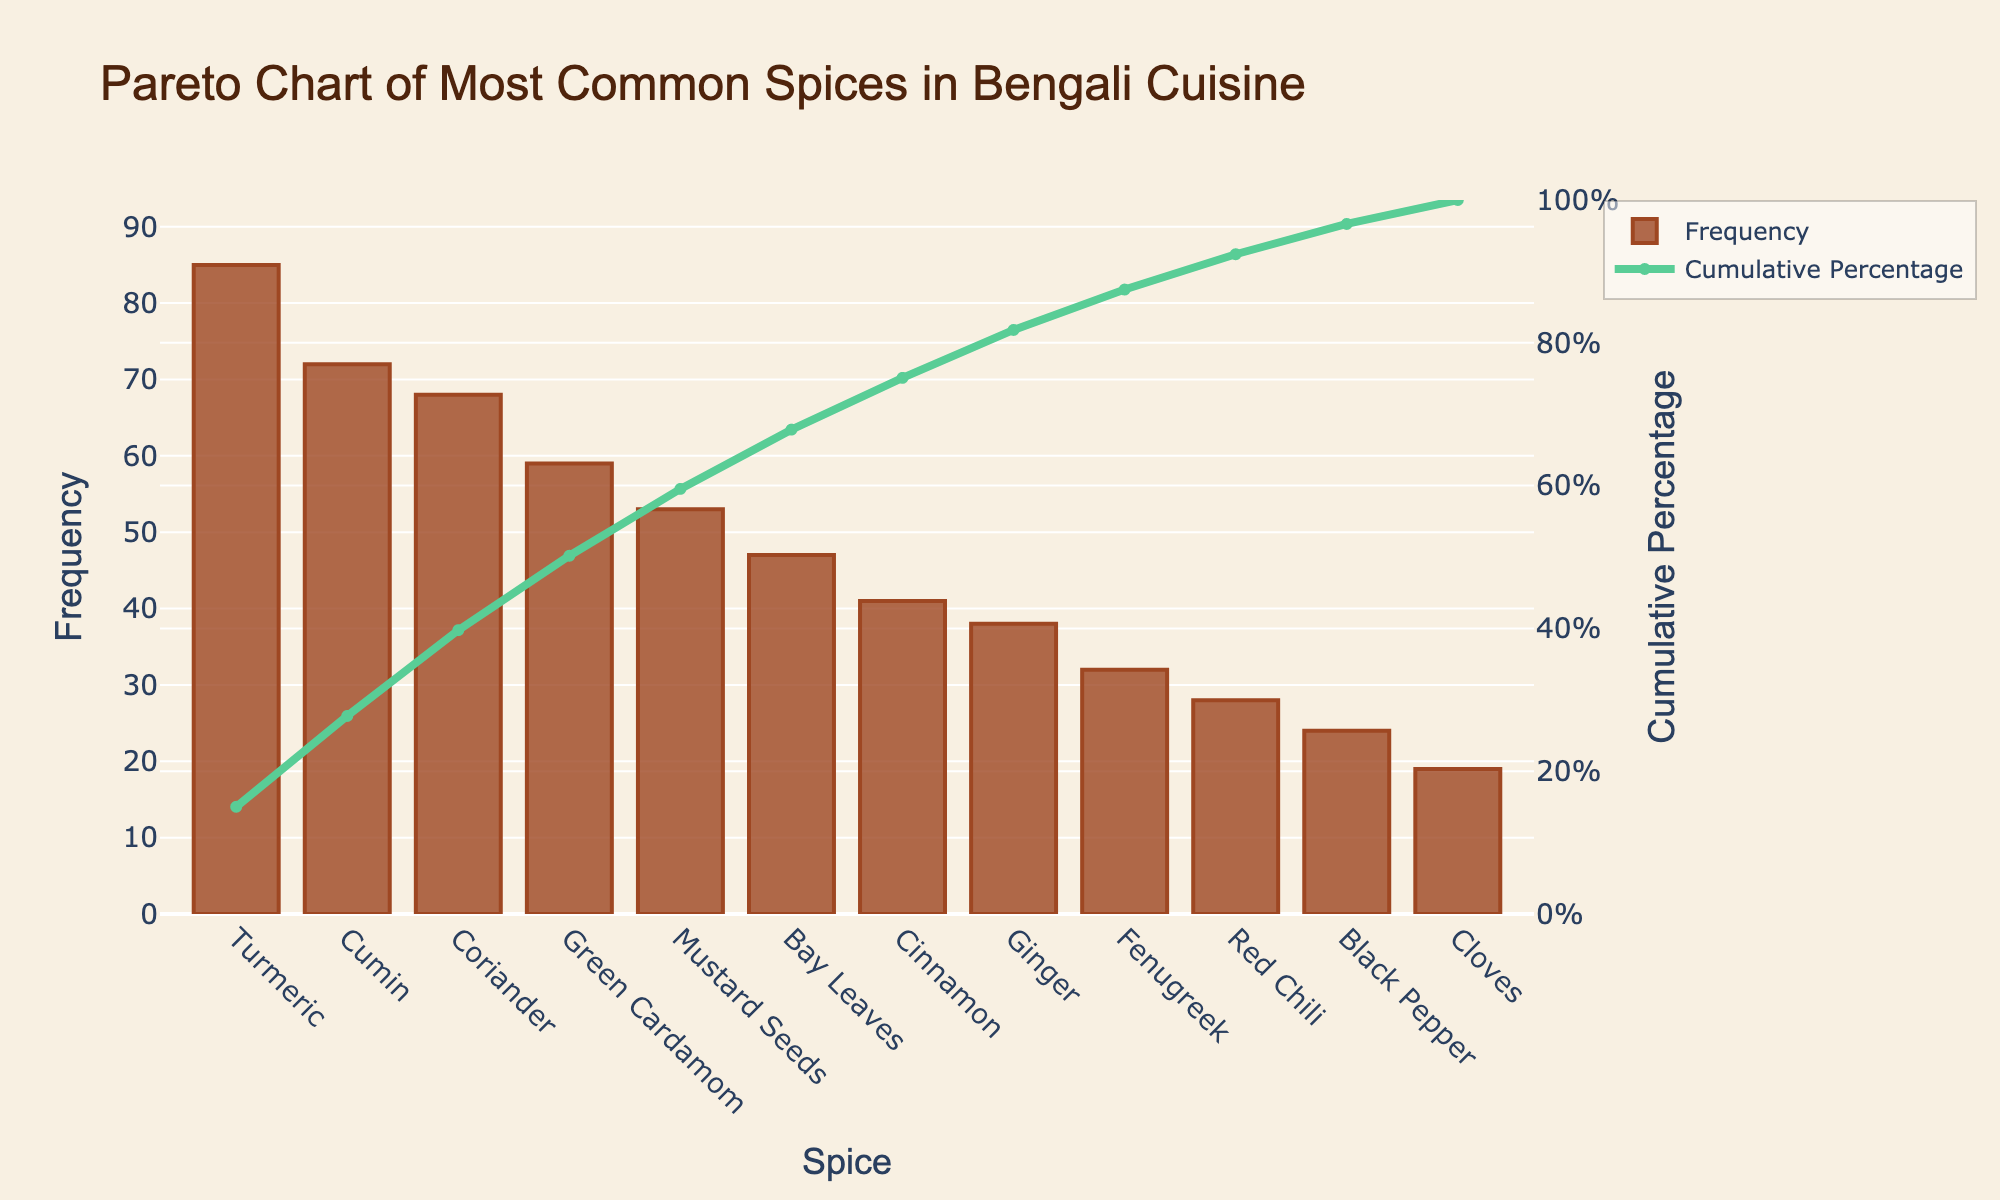What's the title of the figure? The title appears at the top of the figure and provides a summary of what the chart is about. The title is "Pareto Chart of Most Common Spices in Bengali Cuisine".
Answer: Pareto Chart of Most Common Spices in Bengali Cuisine Which spice has the highest frequency of use? By looking at the height of the bars, the spice with the highest frequency is the tallest bar. The spice at the highest bar is Turmeric.
Answer: Turmeric What is the cumulative percentage for Coriander? The cumulative percentage line shows the percentage for each spice. Find Coriander on the x-axis and look at the corresponding point on the cumulative percentage line; it reads approximately 65%.
Answer: ~65% How many spices have a frequency of use greater than 50? Count the number of bars with heights above the frequency value of 50 on the y-axis. Turmeric, Cumin, Coriander, Green Cardamom, and Mustard Seeds meet this criterion. There are 5 spices.
Answer: 5 What's the cumulative percentage for the top three most frequently used spices? The top three spices by frequency are Turmeric, Cumin, and Coriander. Find the corresponding cumulative percentage for Coriander as it represents the sum of the first three spices, which is about 65%.
Answer: ~65% Which spice has a lower frequency of use: Cloves or Red Chili? Compare the bar heights of Cloves and Red Chili. The height of Red Chili is greater than that of Cloves, meaning Cloves has a lower frequency.
Answer: Cloves What does the y-axis on the right represent? The y-axis on the right side of the chart is labeled 'Cumulative Percentage' and shows the cumulative percentage of the frequency values.
Answer: Cumulative Percentage What is the cumulative percentage when adding Red Chili to the sum? Look at the cumulative percentage line corresponding to Red Chili on the x-axis. This is approximately 90%.
Answer: ~90% What is the combined frequency of Ginger and Fenugreek? Find the frequencies for Ginger (38) and Fenugreek (32), and sum them up. The combined frequency is 38 + 32 = 70.
Answer: 70 By what percentage does the cumulative percentage increase from Black Pepper to Bay Leaves? Find the cumulative percentages for Black Pepper and Bay Leaves. For Black Pepper, it's approximately 85%, and for Bay Leaves, it's about 92%. The increase is 92% - 85% = 7%.
Answer: 7% 